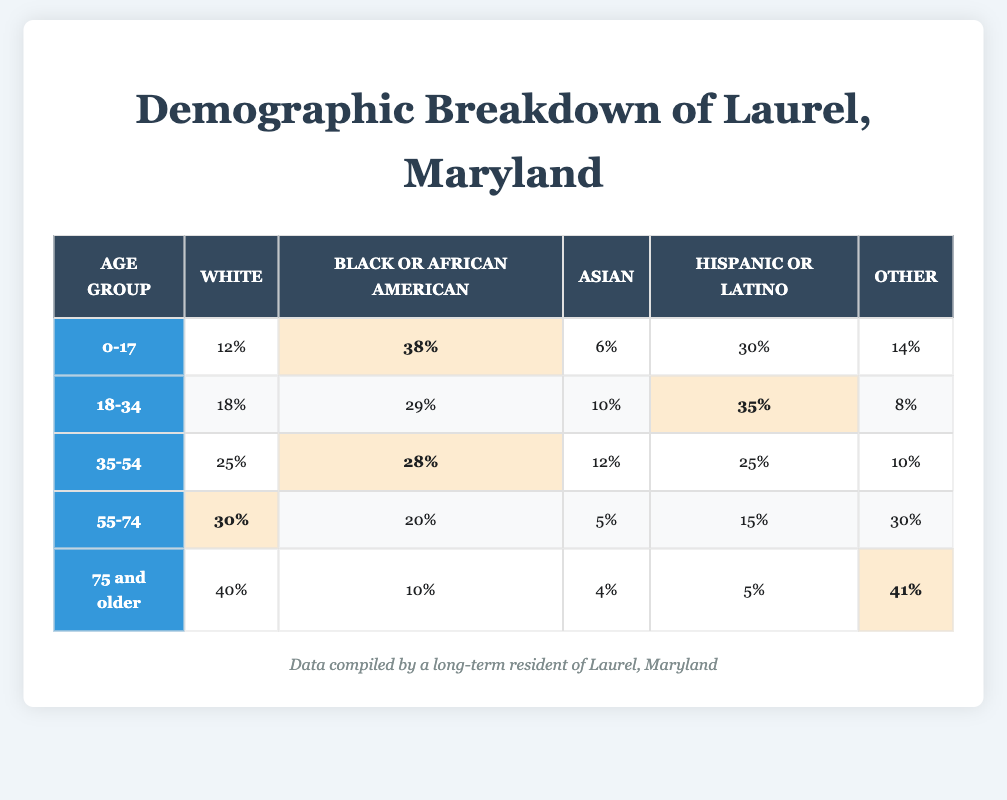What percentage of Laurel residents aged 0-17 are Black or African American? According to the table for the age group 0-17, the percentage of Black or African American residents is listed as 38%.
Answer: 38% Which age group has the highest percentage of White residents? In the table, the age group 75 and older has the highest percentage of White residents at 40%.
Answer: 75 and older What is the total percentage of Asian residents across all age groups? To find the total percentage of Asian residents, we sum the percentage values: 6% (0-17) + 10% (18-34) + 12% (35-54) + 5% (55-74) + 4% (75 and older) = 37%.
Answer: 37% Is the percentage of Hispanic or Latino residents the highest in the age group 18-34? In the age group 18-34, the percentage of Hispanic or Latino residents is 35%, and in the 0-17 age group, it is 30%, but in the 35-54 age group, it's 25%. Therefore, 35% is the highest among the three groups compared.
Answer: Yes What is the percentage difference of Black or African American residents between the age groups 18-34 and 55-74? The percentage of Black or African American residents in the 18-34 age group is 29%, while in the 55-74 age group it is 20%. The difference is 29% - 20% = 9%.
Answer: 9% Which age group represents the highest diversity among ethnicities based on the "Other" category? For the "Other" category, the 75 and older age group has the highest percentage at 41%, compared to 30% in the 55-74 age group, which indicates greater diversity as they have the highest representation.
Answer: 75 and older What is the average percentage of White residents across all age groups? The average is calculated by taking the total percentage of White residents across all age groups and dividing by the number of groups: (12% + 18% + 25% + 30% + 40%) / 5 = 125% / 5 = 25%.
Answer: 25% Are there more Hispanic or Latino residents in the age group 0-17 than in the 75 and older group? The table shows that in the 0-17 age group, the percentage of Hispanic or Latino residents is 30%, whereas in the 75 and older group, it is 5%. Therefore, there are more in the younger group.
Answer: Yes What is the percentage of residents aged 55-74 who identify as either Asian or Other? The percentage of Asian residents in the 55-74 age group is 5%, and for Other, it is 30%. Adding these together gives 5% + 30% = 35%.
Answer: 35% 